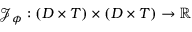<formula> <loc_0><loc_0><loc_500><loc_500>\mathcal { J } _ { \phi } \colon \left ( D \times T \right ) \times \left ( D \times T \right ) \rightarrow \mathbb { R }</formula> 